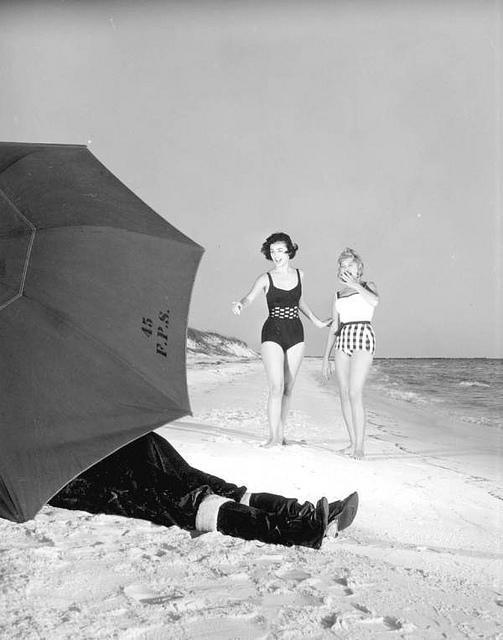How many people can you see?
Give a very brief answer. 3. 